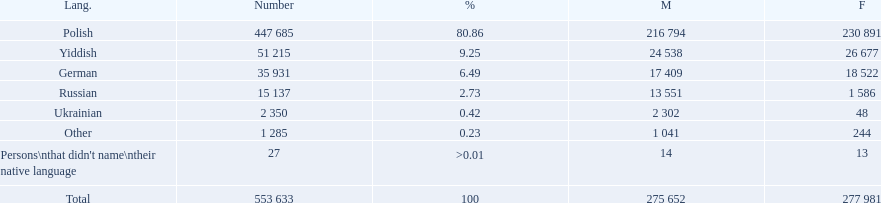What language makes a majority Polish. What the the total number of speakers? 553 633. 